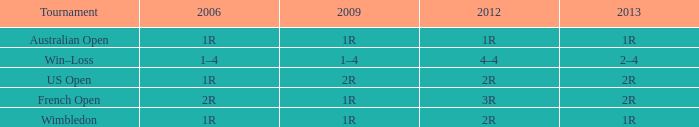What shows for 2013 when the 2012 is 2r, and a 2009 is 2r? 2R. 